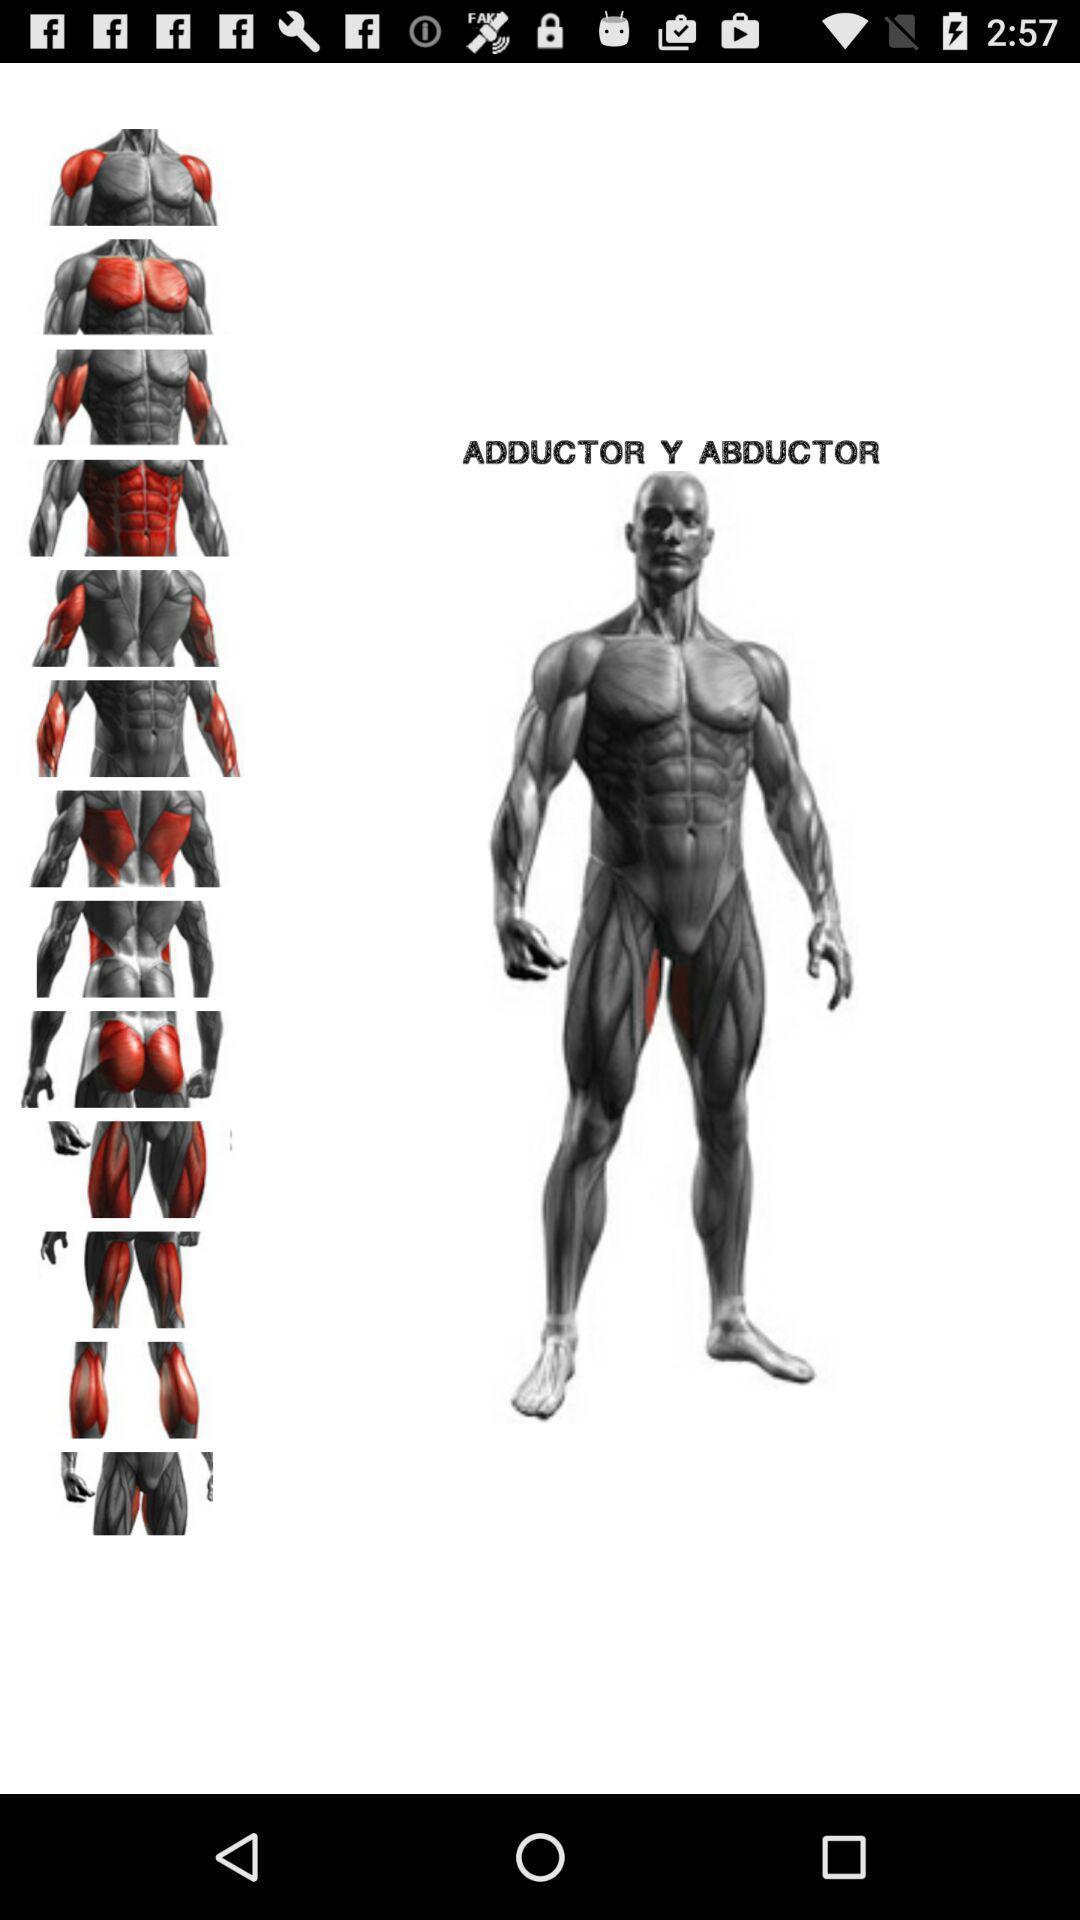Give me a summary of this screen capture. Various body parts in the application with animated pics. 